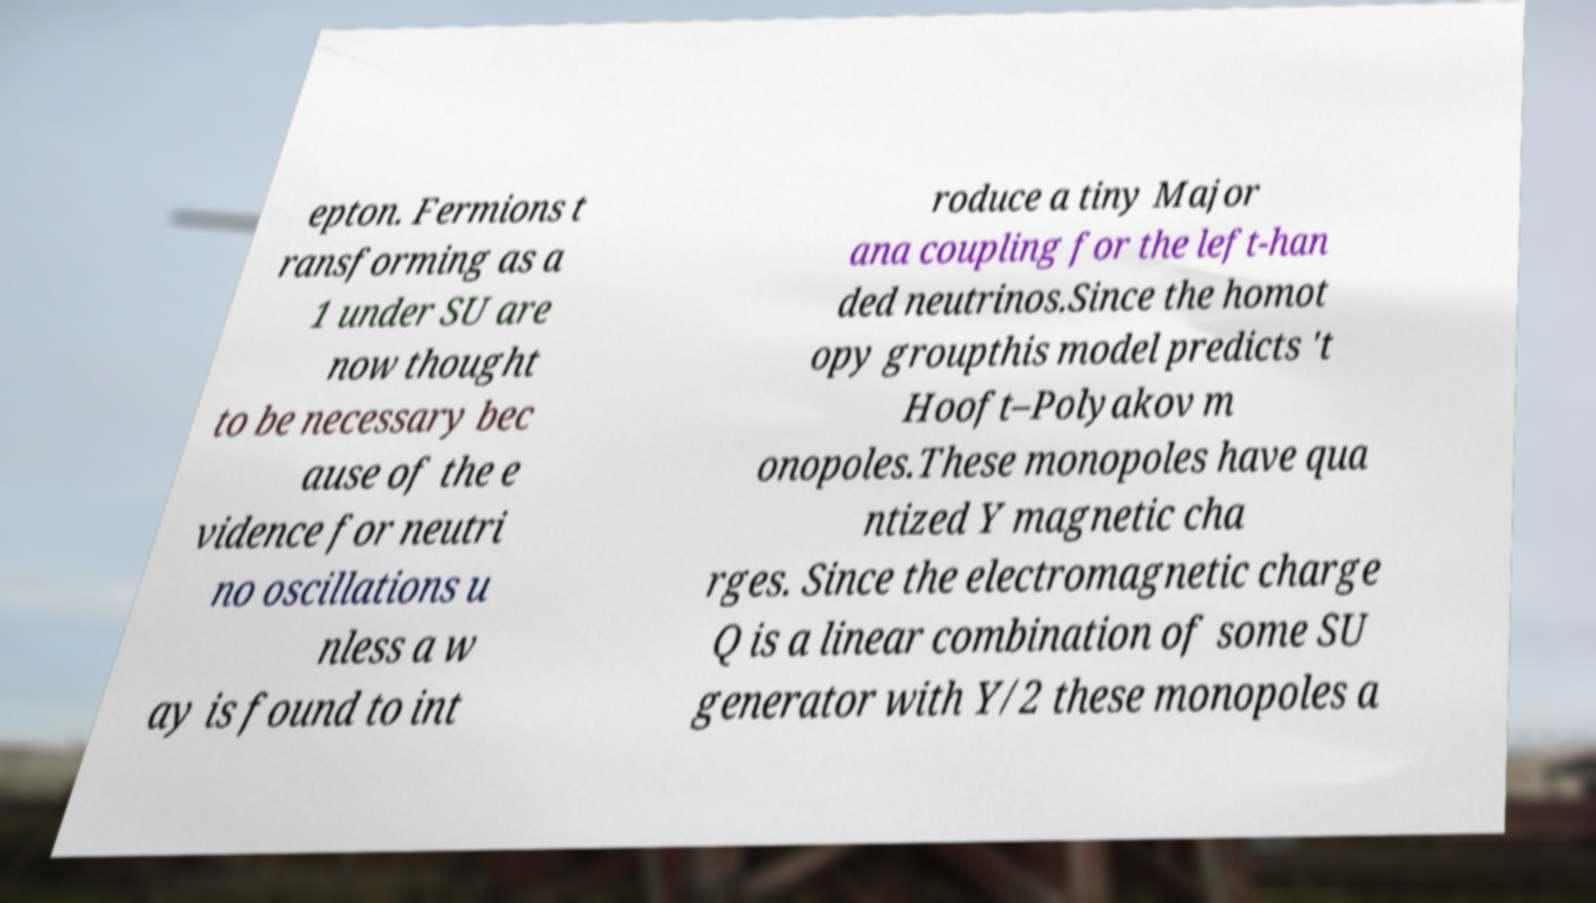Can you accurately transcribe the text from the provided image for me? epton. Fermions t ransforming as a 1 under SU are now thought to be necessary bec ause of the e vidence for neutri no oscillations u nless a w ay is found to int roduce a tiny Major ana coupling for the left-han ded neutrinos.Since the homot opy groupthis model predicts 't Hooft–Polyakov m onopoles.These monopoles have qua ntized Y magnetic cha rges. Since the electromagnetic charge Q is a linear combination of some SU generator with Y/2 these monopoles a 